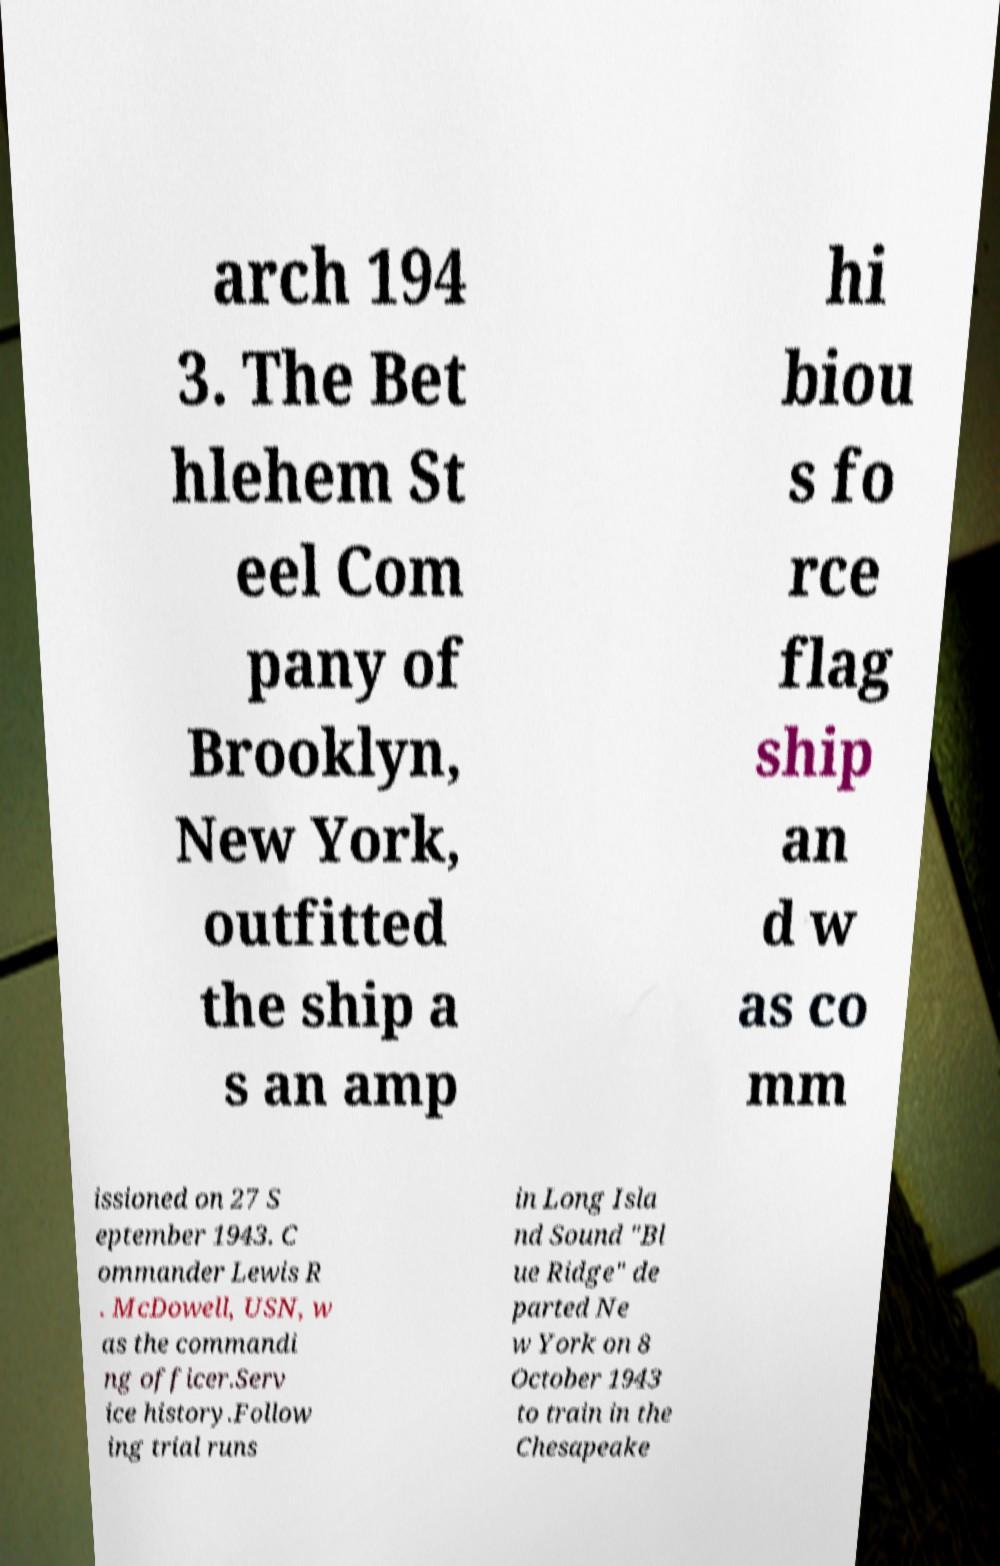Can you read and provide the text displayed in the image?This photo seems to have some interesting text. Can you extract and type it out for me? arch 194 3. The Bet hlehem St eel Com pany of Brooklyn, New York, outfitted the ship a s an amp hi biou s fo rce flag ship an d w as co mm issioned on 27 S eptember 1943. C ommander Lewis R . McDowell, USN, w as the commandi ng officer.Serv ice history.Follow ing trial runs in Long Isla nd Sound "Bl ue Ridge" de parted Ne w York on 8 October 1943 to train in the Chesapeake 